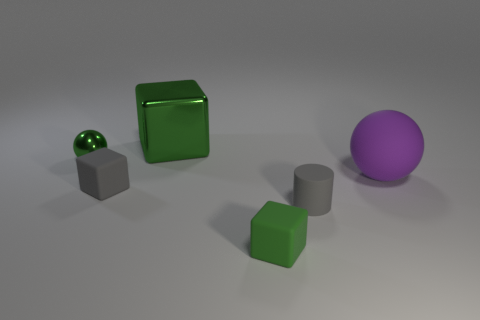Do the objects in the image serve a specific function? From the image alone, it is not clear whether these objects serve a specific real-world function as they appear to be geometric shapes that could be used for various purposes, including educational models, design elements, or purely decorative items. Their function may also be context-dependent, such as part of an art installation or a computer graphics rendering test. 